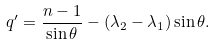<formula> <loc_0><loc_0><loc_500><loc_500>q ^ { \prime } = \frac { n - 1 } { \sin \theta } - ( \lambda _ { 2 } - \lambda _ { 1 } ) \sin \theta .</formula> 